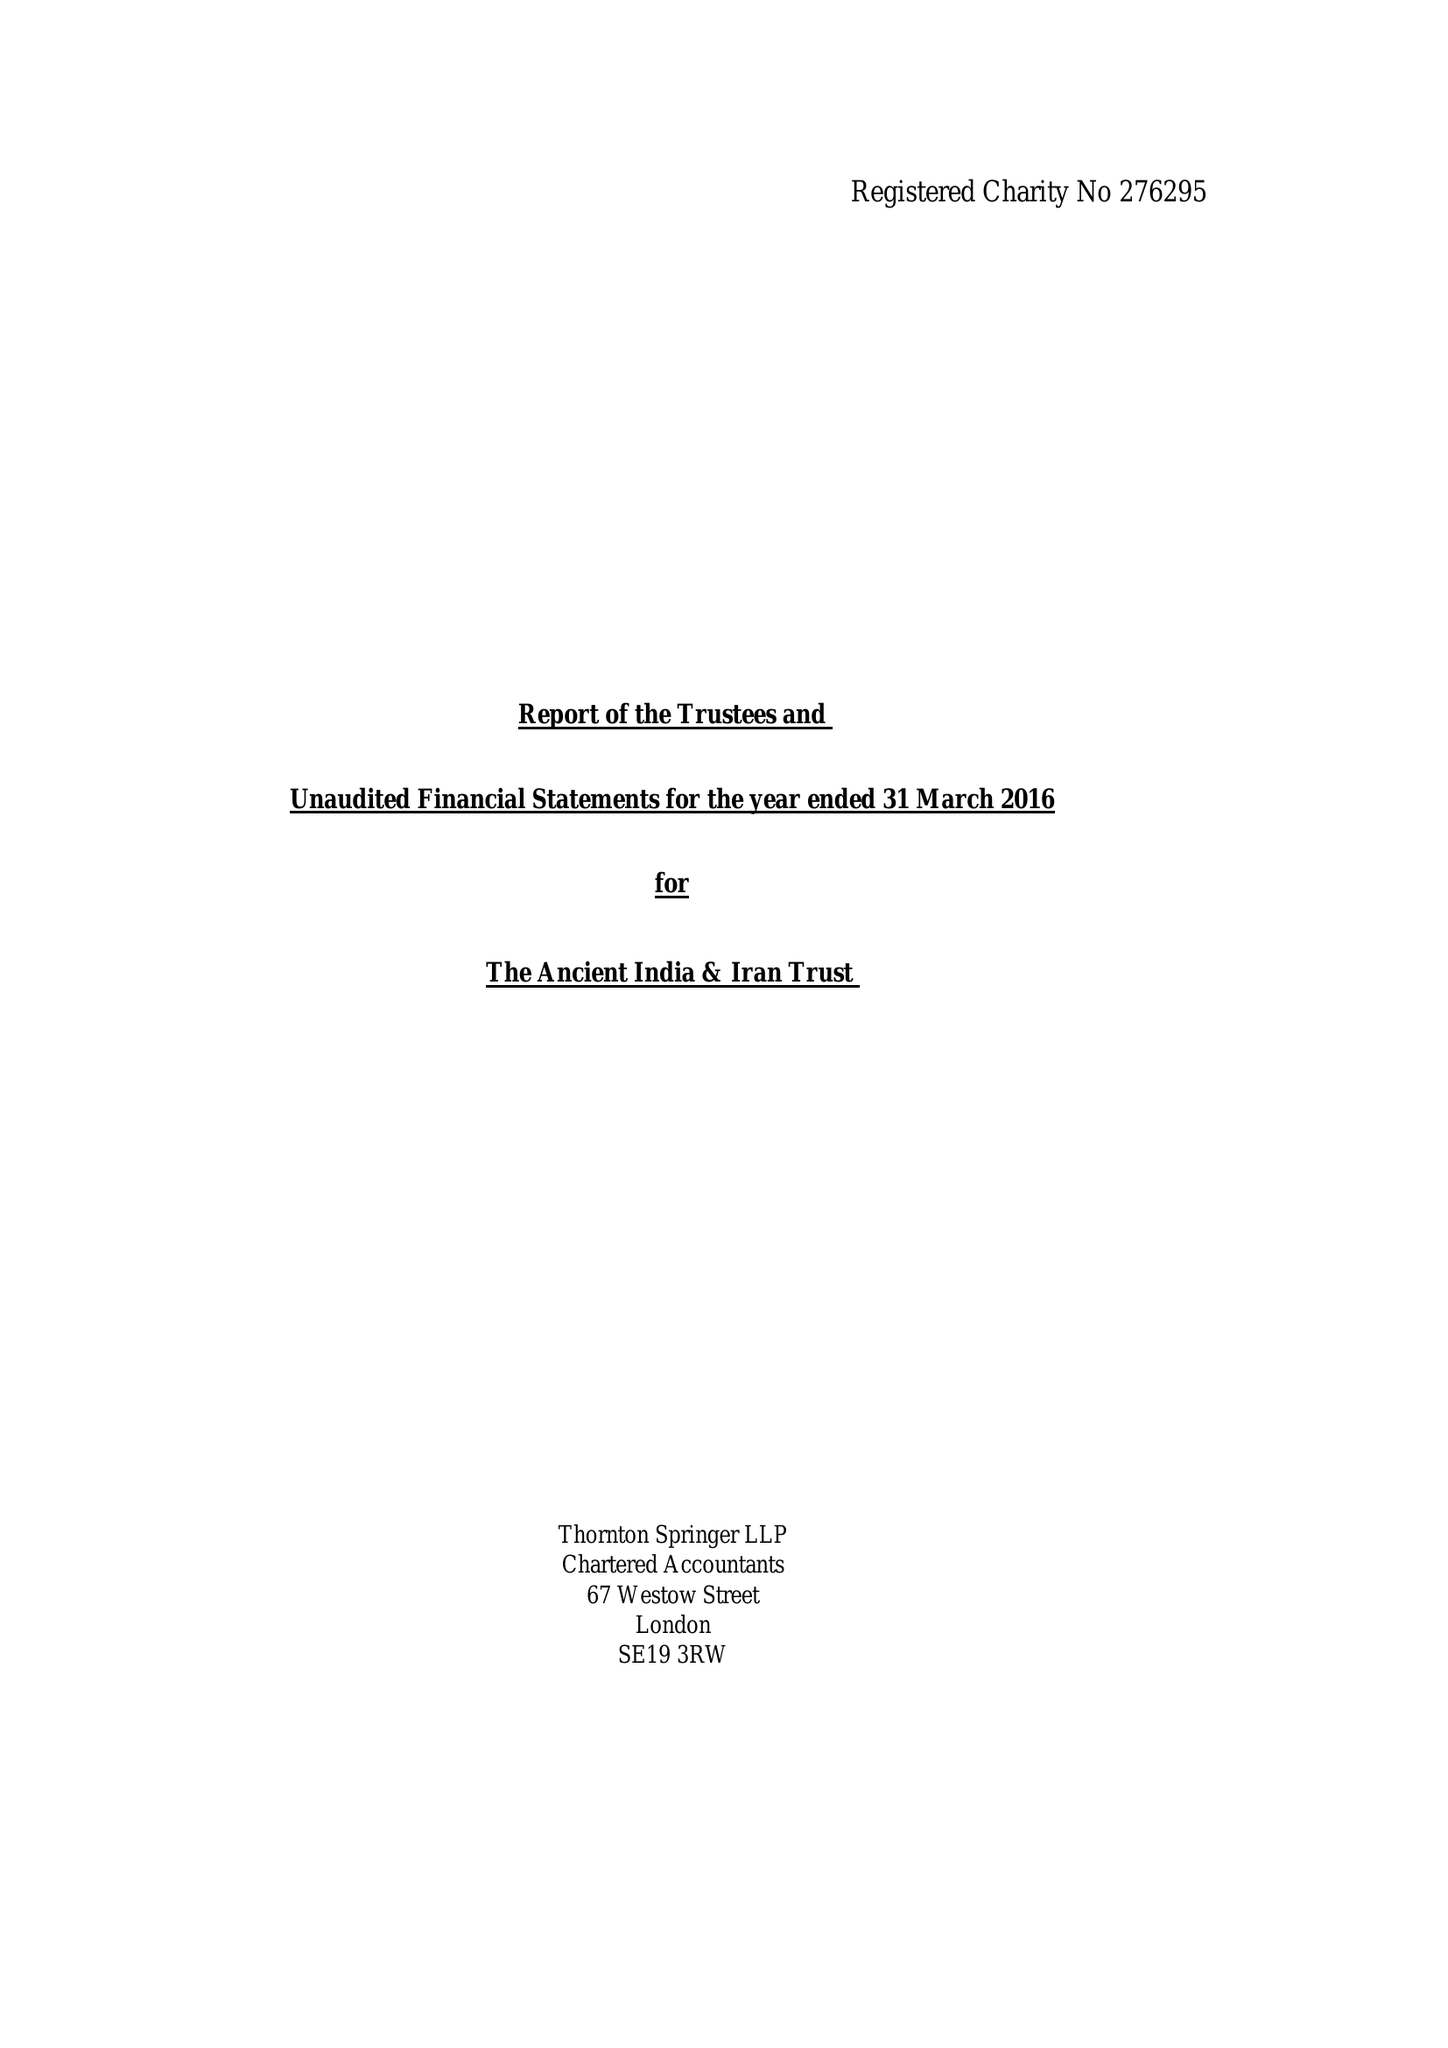What is the value for the address__postcode?
Answer the question using a single word or phrase. CB2 8BG 